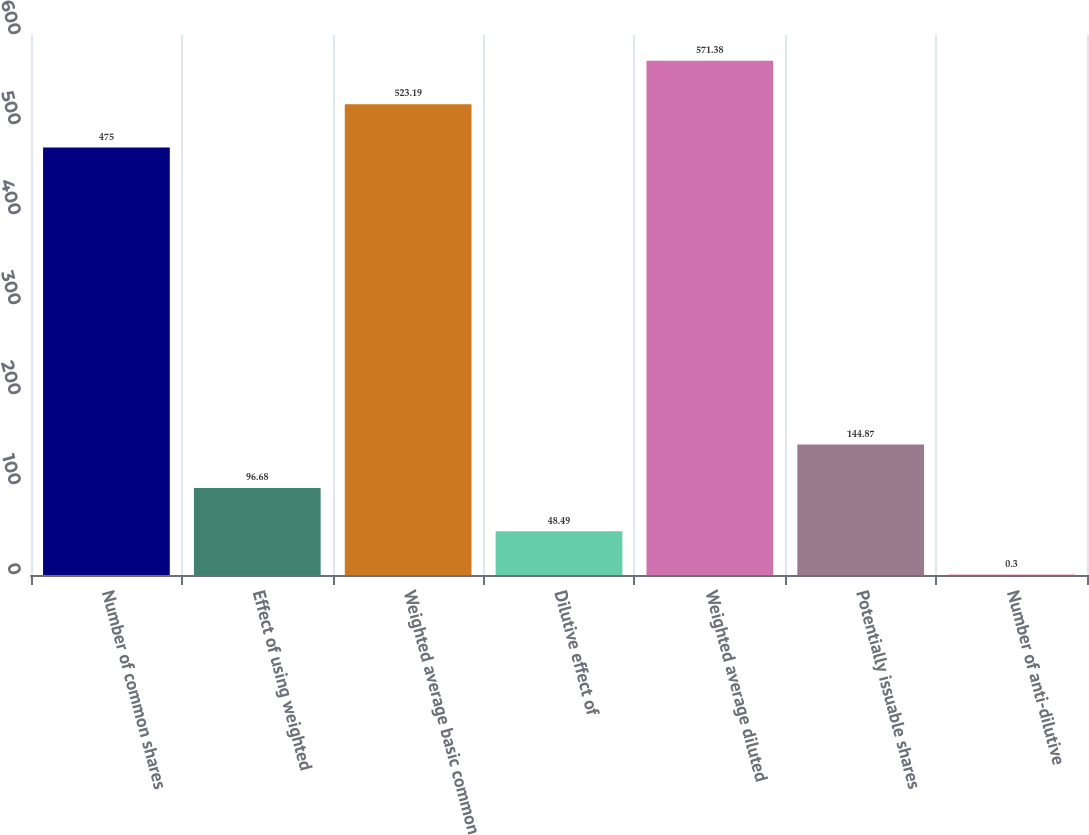<chart> <loc_0><loc_0><loc_500><loc_500><bar_chart><fcel>Number of common shares<fcel>Effect of using weighted<fcel>Weighted average basic common<fcel>Dilutive effect of<fcel>Weighted average diluted<fcel>Potentially issuable shares<fcel>Number of anti-dilutive<nl><fcel>475<fcel>96.68<fcel>523.19<fcel>48.49<fcel>571.38<fcel>144.87<fcel>0.3<nl></chart> 